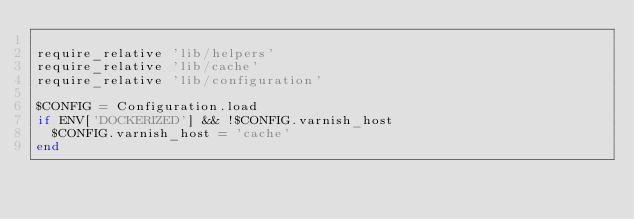Convert code to text. <code><loc_0><loc_0><loc_500><loc_500><_Ruby_>
require_relative 'lib/helpers'
require_relative 'lib/cache'
require_relative 'lib/configuration'

$CONFIG = Configuration.load
if ENV['DOCKERIZED'] && !$CONFIG.varnish_host
  $CONFIG.varnish_host = 'cache'
end
</code> 